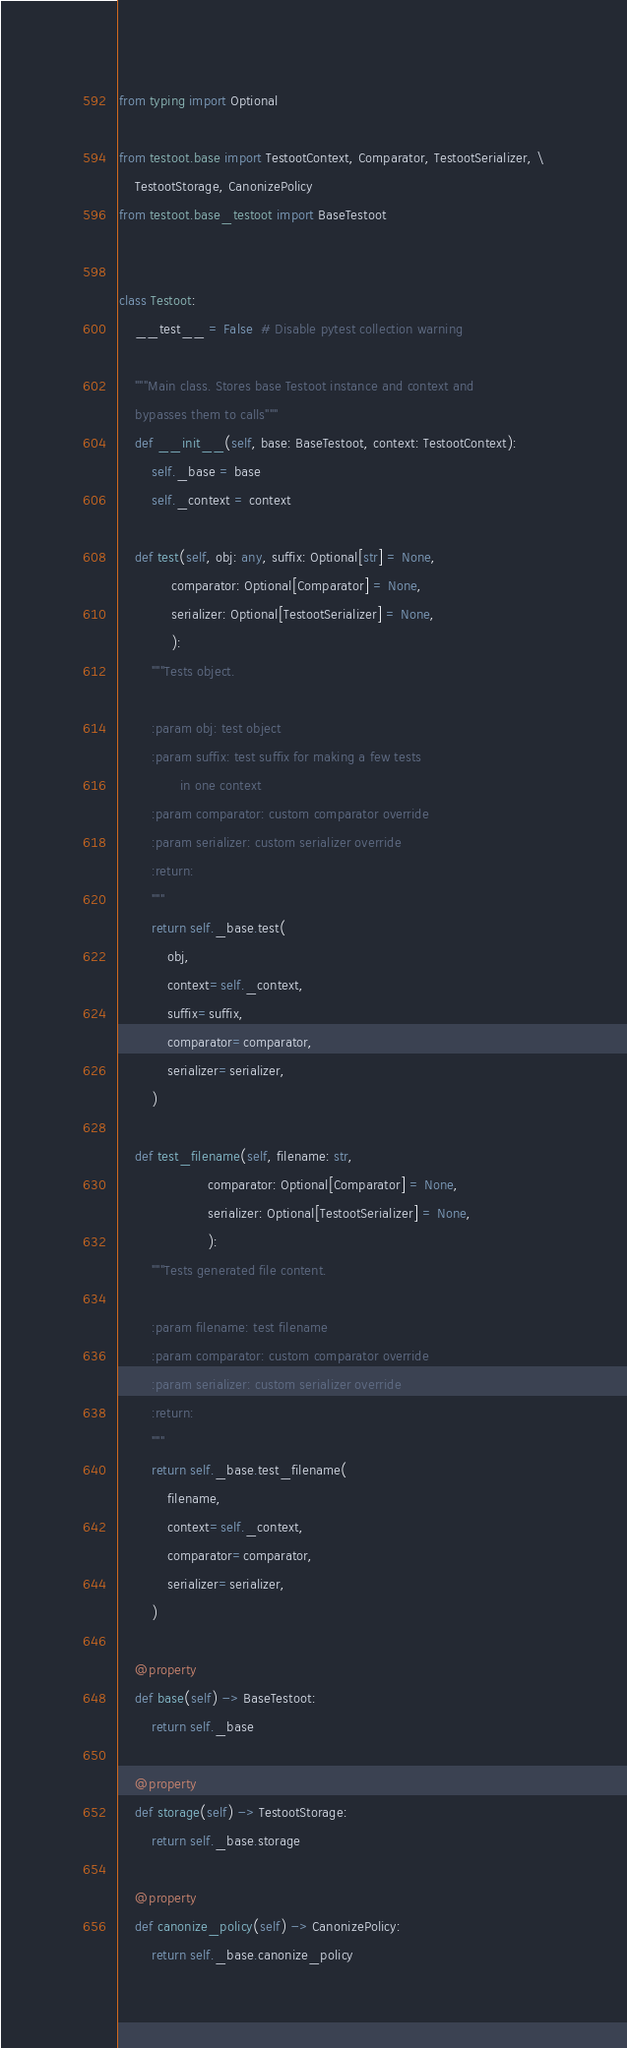<code> <loc_0><loc_0><loc_500><loc_500><_Python_>from typing import Optional

from testoot.base import TestootContext, Comparator, TestootSerializer, \
    TestootStorage, CanonizePolicy
from testoot.base_testoot import BaseTestoot


class Testoot:
    __test__ = False  # Disable pytest collection warning

    """Main class. Stores base Testoot instance and context and
    bypasses them to calls"""
    def __init__(self, base: BaseTestoot, context: TestootContext):
        self._base = base
        self._context = context

    def test(self, obj: any, suffix: Optional[str] = None,
             comparator: Optional[Comparator] = None,
             serializer: Optional[TestootSerializer] = None,
             ):
        """Tests object.

        :param obj: test object
        :param suffix: test suffix for making a few tests
               in one context
        :param comparator: custom comparator override
        :param serializer: custom serializer override
        :return:
        """
        return self._base.test(
            obj,
            context=self._context,
            suffix=suffix,
            comparator=comparator,
            serializer=serializer,
        )

    def test_filename(self, filename: str,
                      comparator: Optional[Comparator] = None,
                      serializer: Optional[TestootSerializer] = None,
                      ):
        """Tests generated file content.

        :param filename: test filename
        :param comparator: custom comparator override
        :param serializer: custom serializer override
        :return:
        """
        return self._base.test_filename(
            filename,
            context=self._context,
            comparator=comparator,
            serializer=serializer,
        )

    @property
    def base(self) -> BaseTestoot:
        return self._base

    @property
    def storage(self) -> TestootStorage:
        return self._base.storage

    @property
    def canonize_policy(self) -> CanonizePolicy:
        return self._base.canonize_policy
</code> 